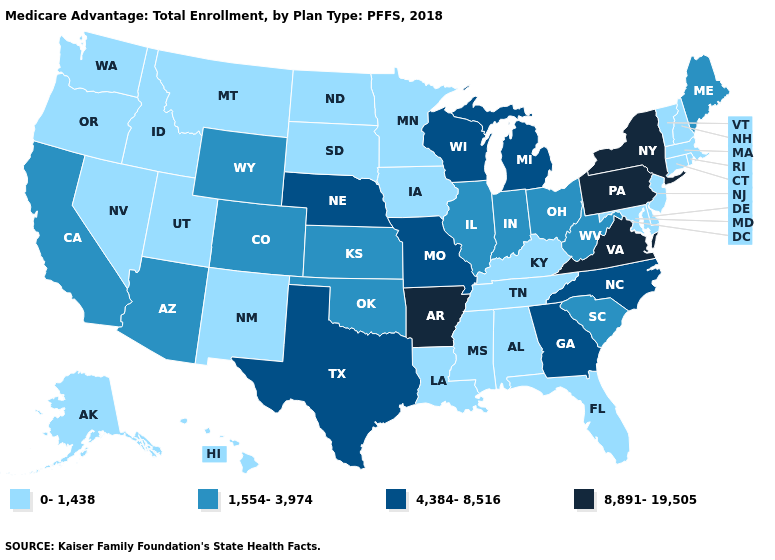Name the states that have a value in the range 4,384-8,516?
Answer briefly. Georgia, Michigan, Missouri, Nebraska, North Carolina, Texas, Wisconsin. What is the value of North Dakota?
Answer briefly. 0-1,438. Name the states that have a value in the range 4,384-8,516?
Quick response, please. Georgia, Michigan, Missouri, Nebraska, North Carolina, Texas, Wisconsin. Does the map have missing data?
Concise answer only. No. Does Washington have a lower value than Hawaii?
Concise answer only. No. What is the lowest value in states that border Kansas?
Concise answer only. 1,554-3,974. Name the states that have a value in the range 4,384-8,516?
Quick response, please. Georgia, Michigan, Missouri, Nebraska, North Carolina, Texas, Wisconsin. Which states have the lowest value in the West?
Write a very short answer. Alaska, Hawaii, Idaho, Montana, Nevada, New Mexico, Oregon, Utah, Washington. Among the states that border Michigan , which have the lowest value?
Be succinct. Indiana, Ohio. What is the highest value in states that border Florida?
Quick response, please. 4,384-8,516. Which states have the lowest value in the MidWest?
Keep it brief. Iowa, Minnesota, North Dakota, South Dakota. Which states hav the highest value in the MidWest?
Answer briefly. Michigan, Missouri, Nebraska, Wisconsin. Does the first symbol in the legend represent the smallest category?
Short answer required. Yes. Does the first symbol in the legend represent the smallest category?
Keep it brief. Yes. Which states have the lowest value in the USA?
Be succinct. Alabama, Alaska, Connecticut, Delaware, Florida, Hawaii, Idaho, Iowa, Kentucky, Louisiana, Maryland, Massachusetts, Minnesota, Mississippi, Montana, Nevada, New Hampshire, New Jersey, New Mexico, North Dakota, Oregon, Rhode Island, South Dakota, Tennessee, Utah, Vermont, Washington. 